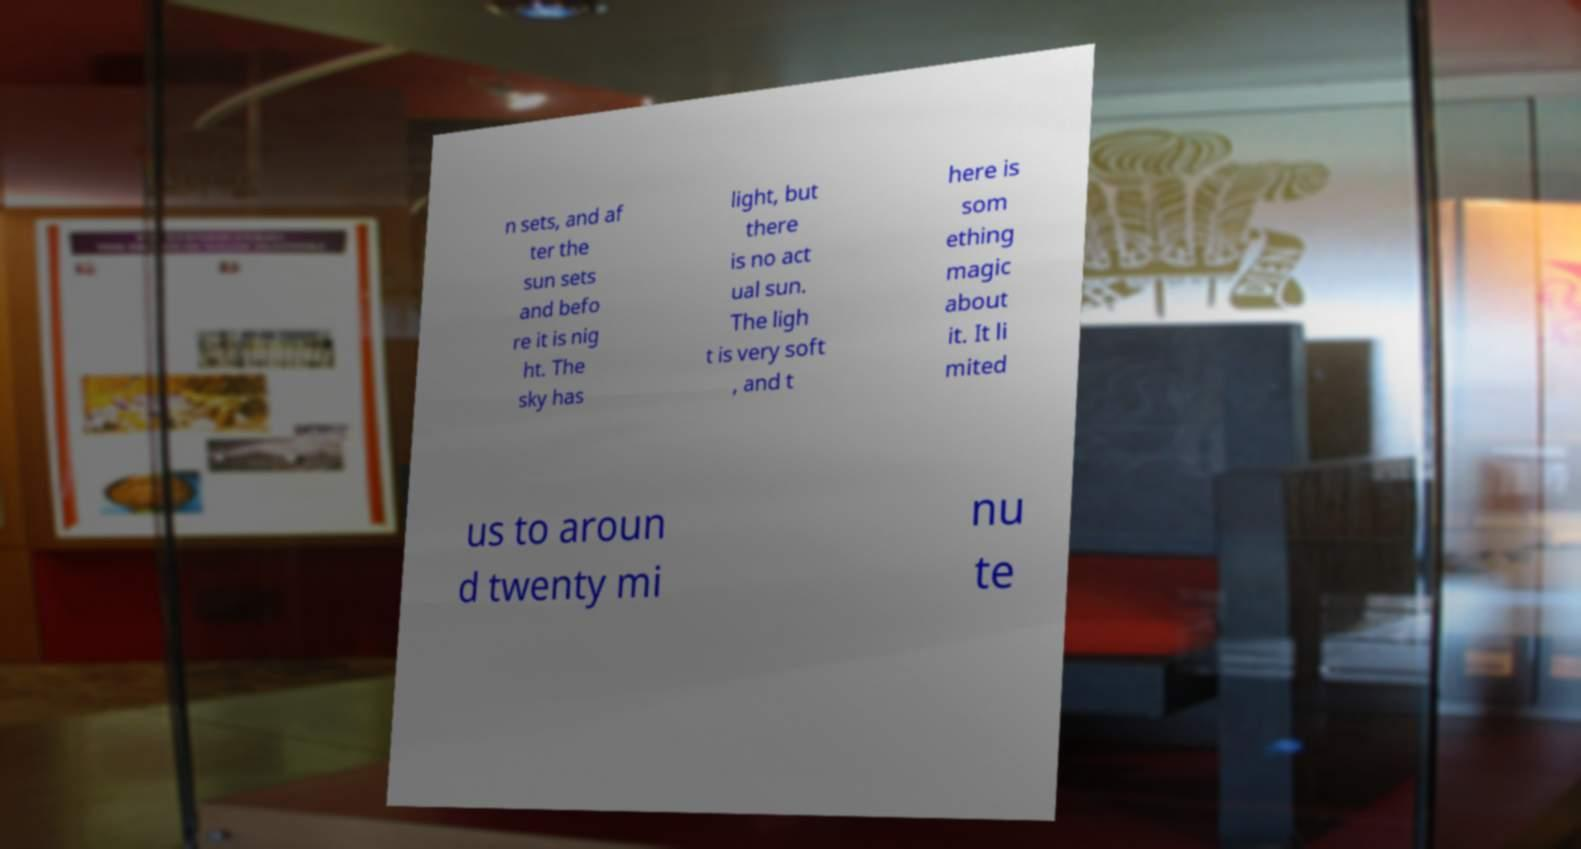I need the written content from this picture converted into text. Can you do that? n sets, and af ter the sun sets and befo re it is nig ht. The sky has light, but there is no act ual sun. The ligh t is very soft , and t here is som ething magic about it. It li mited us to aroun d twenty mi nu te 